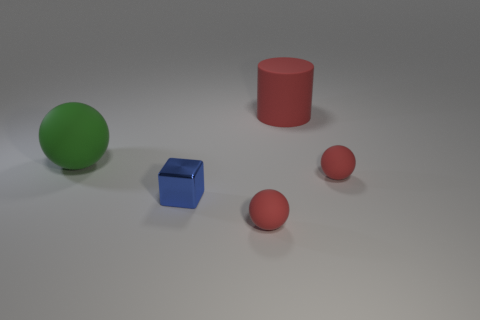There is a blue cube; is it the same size as the sphere in front of the tiny blue object?
Provide a short and direct response. Yes. There is a object that is behind the large green matte ball; are there any large green rubber objects behind it?
Give a very brief answer. No. There is a large rubber thing behind the large green matte thing; what is its shape?
Your response must be concise. Cylinder. There is a tiny shiny cube that is to the left of the matte sphere that is in front of the tiny block; what color is it?
Your response must be concise. Blue. Do the blue metal cube and the green thing have the same size?
Offer a terse response. No. What number of green objects have the same size as the green sphere?
Make the answer very short. 0. The other big object that is made of the same material as the large red object is what color?
Offer a terse response. Green. Are there fewer purple matte objects than big spheres?
Offer a very short reply. Yes. How many green things are big objects or metal objects?
Give a very brief answer. 1. What number of matte spheres are both behind the tiny block and to the right of the large green matte ball?
Your answer should be very brief. 1. 